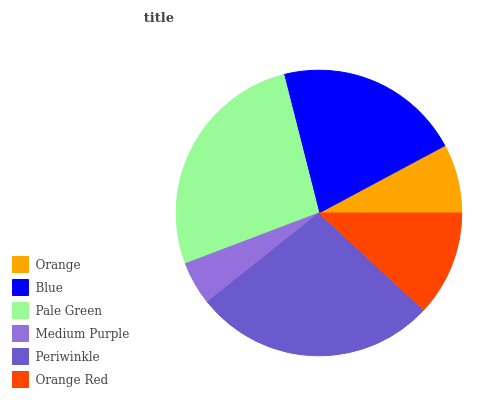Is Medium Purple the minimum?
Answer yes or no. Yes. Is Periwinkle the maximum?
Answer yes or no. Yes. Is Blue the minimum?
Answer yes or no. No. Is Blue the maximum?
Answer yes or no. No. Is Blue greater than Orange?
Answer yes or no. Yes. Is Orange less than Blue?
Answer yes or no. Yes. Is Orange greater than Blue?
Answer yes or no. No. Is Blue less than Orange?
Answer yes or no. No. Is Blue the high median?
Answer yes or no. Yes. Is Orange Red the low median?
Answer yes or no. Yes. Is Pale Green the high median?
Answer yes or no. No. Is Periwinkle the low median?
Answer yes or no. No. 